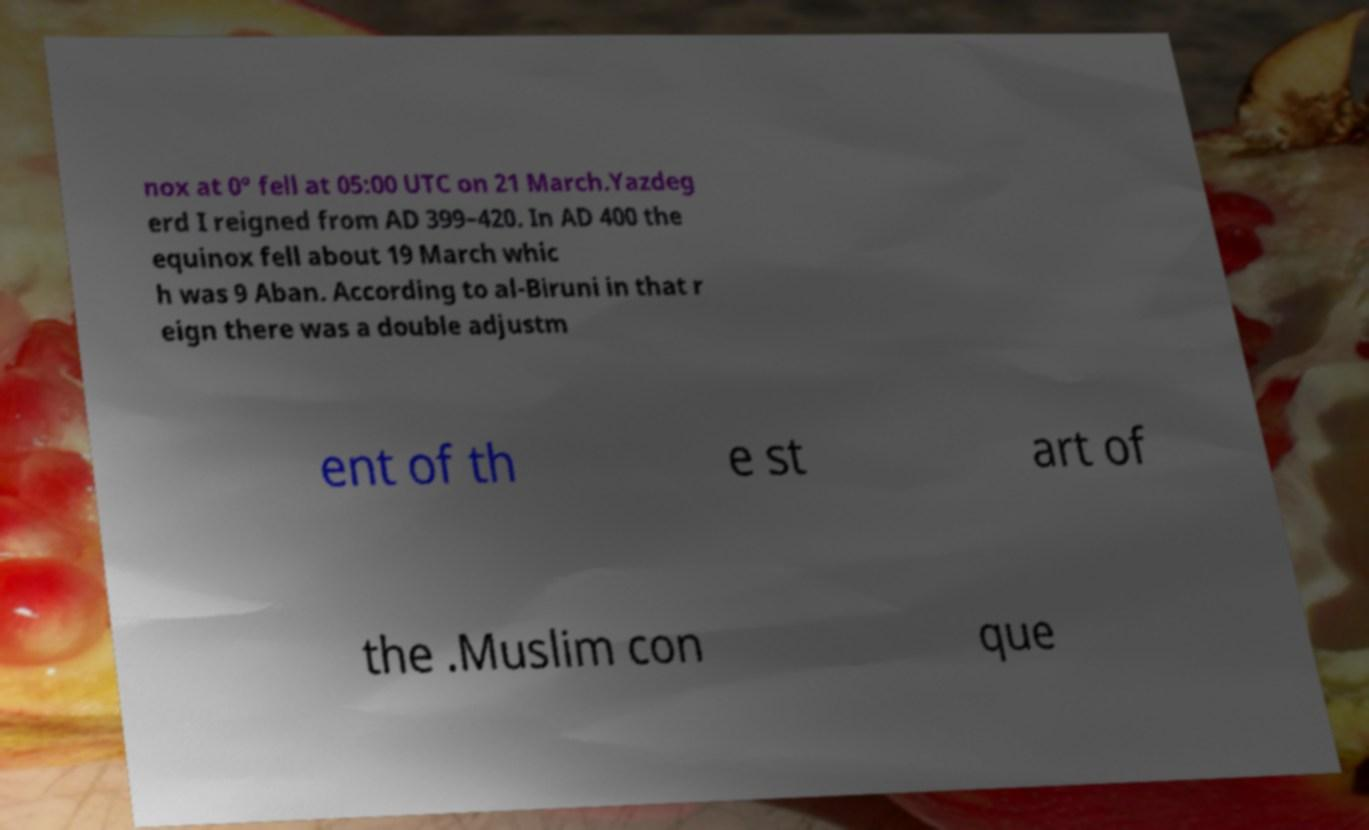For documentation purposes, I need the text within this image transcribed. Could you provide that? nox at 0° fell at 05:00 UTC on 21 March.Yazdeg erd I reigned from AD 399–420. In AD 400 the equinox fell about 19 March whic h was 9 Aban. According to al-Biruni in that r eign there was a double adjustm ent of th e st art of the .Muslim con que 